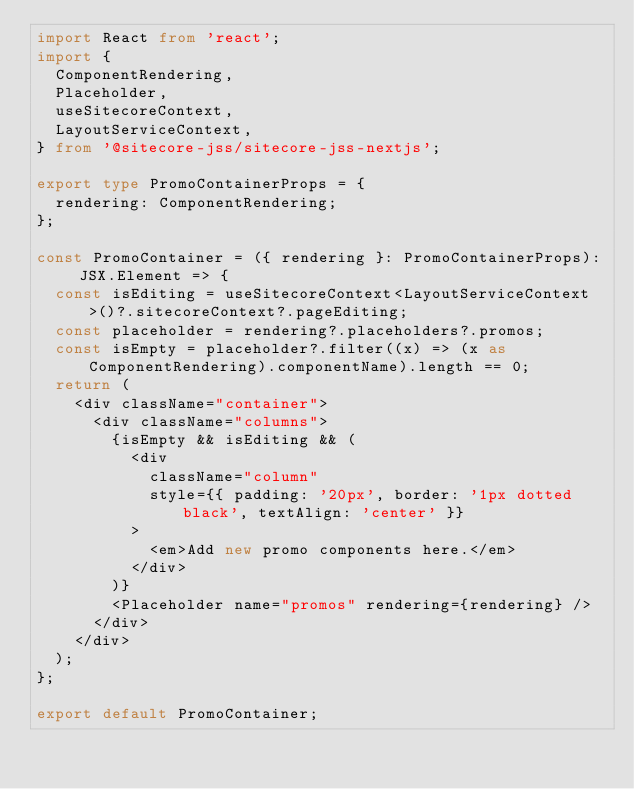Convert code to text. <code><loc_0><loc_0><loc_500><loc_500><_TypeScript_>import React from 'react';
import {
  ComponentRendering,
  Placeholder,
  useSitecoreContext,
  LayoutServiceContext,
} from '@sitecore-jss/sitecore-jss-nextjs';

export type PromoContainerProps = {
  rendering: ComponentRendering;
};

const PromoContainer = ({ rendering }: PromoContainerProps): JSX.Element => {
  const isEditing = useSitecoreContext<LayoutServiceContext>()?.sitecoreContext?.pageEditing;
  const placeholder = rendering?.placeholders?.promos;
  const isEmpty = placeholder?.filter((x) => (x as ComponentRendering).componentName).length == 0;
  return (
    <div className="container">
      <div className="columns">
        {isEmpty && isEditing && (
          <div
            className="column"
            style={{ padding: '20px', border: '1px dotted black', textAlign: 'center' }}
          >
            <em>Add new promo components here.</em>
          </div>
        )}
        <Placeholder name="promos" rendering={rendering} />
      </div>
    </div>
  );
};

export default PromoContainer;
</code> 